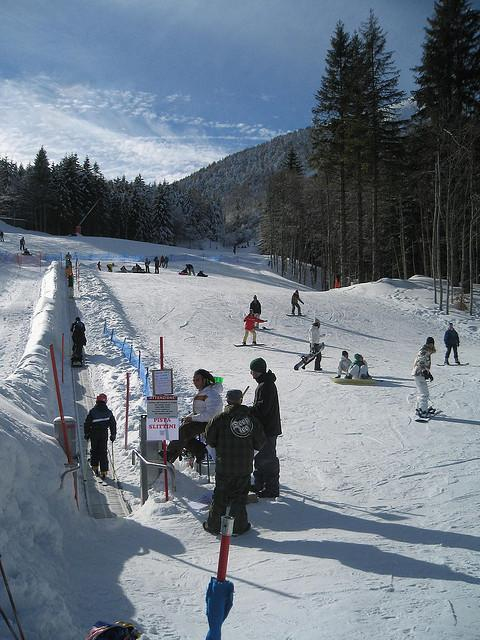What level of skier is this part of the hill designed for? beginner 